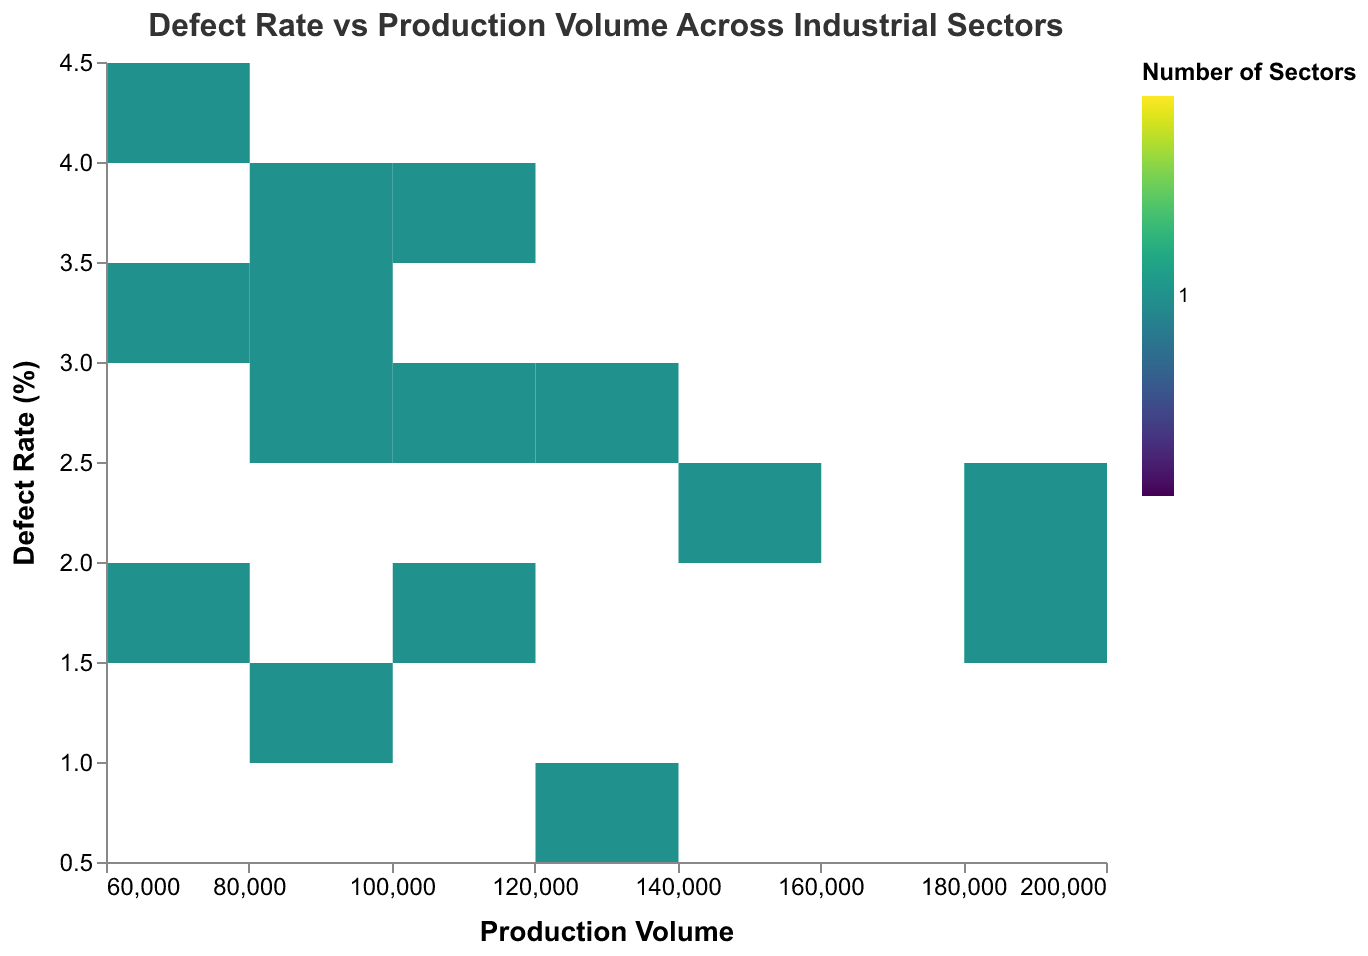What's the title of the plot? The title of the plot is usually displayed at the top of the figure. In this case, the title is "Defect Rate vs Production Volume Across Industrial Sectors"
Answer: "Defect Rate vs Production Volume Across Industrial Sectors" What is the range of the defect rate represented on the y-axis? The y-axis displays the defect rate and it ranges from the minimum defect rate to the maximum defect rate seen in the data. The given data has defect rates ranging from 0.7% to 4.2% as observed in the figure.
Answer: 0.7% to 4.2% Which industrial sector has the highest defect rate? The highest defect rate can be observed by looking at the data points plotted on the y-axis. In this case, the sector with the highest defect rate of 4.2% is "Mining Equipment."
Answer: Mining Equipment How does the defect rate of "Defense" compare to that of "Aerospace"? To compare the defect rates, we locate the points for "Defense" and "Aerospace" on the y-axis. "Defense" has a defect rate of 1.8%, whereas "Aerospace" has a defect rate of 1.1%. Hence, "Defense" has a higher defect rate than "Aerospace."
Answer: Higher What is the axis label for production volume? The axis label for production volume is usually identified next to the axis itself. In this case, the x-axis represents the "Production Volume" and it is labeled as such in the plot.
Answer: Production Volume How many sectors have a defect rate within the range of 2-3%? To determine the number of sectors within a given defect rate range, we can count the points that fall within 2-3% on the y-axis. From the data, "Automotive," "Power Generation," "Railway," "Tooling," "Consumer Appliances," and "Renewable Energy" fall within this range. There are 6 sectors in total.
Answer: 6 What are the characteristics of sectors with the highest production volume? The sectors with the highest production volumes will be located towards the right end of the x-axis. "Electronics" and "Consumer Appliances" have production volumes of 200,000 and 180,000 respectively. Both these sectors have defect rates within the range of 1.5-2.1%.
Answer: High production volume, Defect rates 1.5-2.1% Do higher production volumes correlate with lower defect rates? To determine if there is a correlation, observe the distribution of points on the plot. Sectors with larger production volumes (e.g., "Electronics," "Consumer Appliances") seem to have relatively lower defect rates compared to those with smaller volumes, suggesting a general trend.
Answer: Suggests negative correlation Which sector has the lowest production volume and what is its defect rate? The sector with the lowest production volume is identified by locating the leftmost point on the x-axis. This point belongs to "Marine Engineering" with a production volume of 65,000 and a defect rate of 3.1%.
Answer: Marine Engineering, 3.1% 